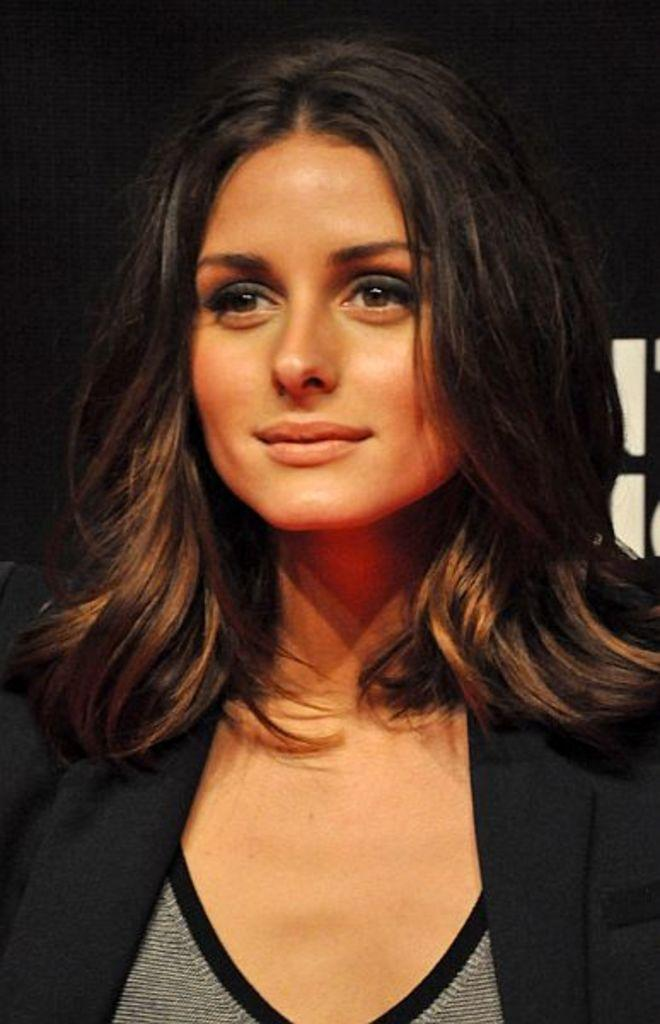Who is the main subject in the image? There is a woman in the image. What is the woman wearing in the image? The woman is wearing a black coat. What is the woman's facial expression in the image? The woman is smiling in the image. What is the woman doing in the image? The woman is posing for the camera. What type of nail is the woman holding in the image? There is no nail present in the image. Is the woman wearing a hat in the image? No, the woman is not wearing a hat in the image. 